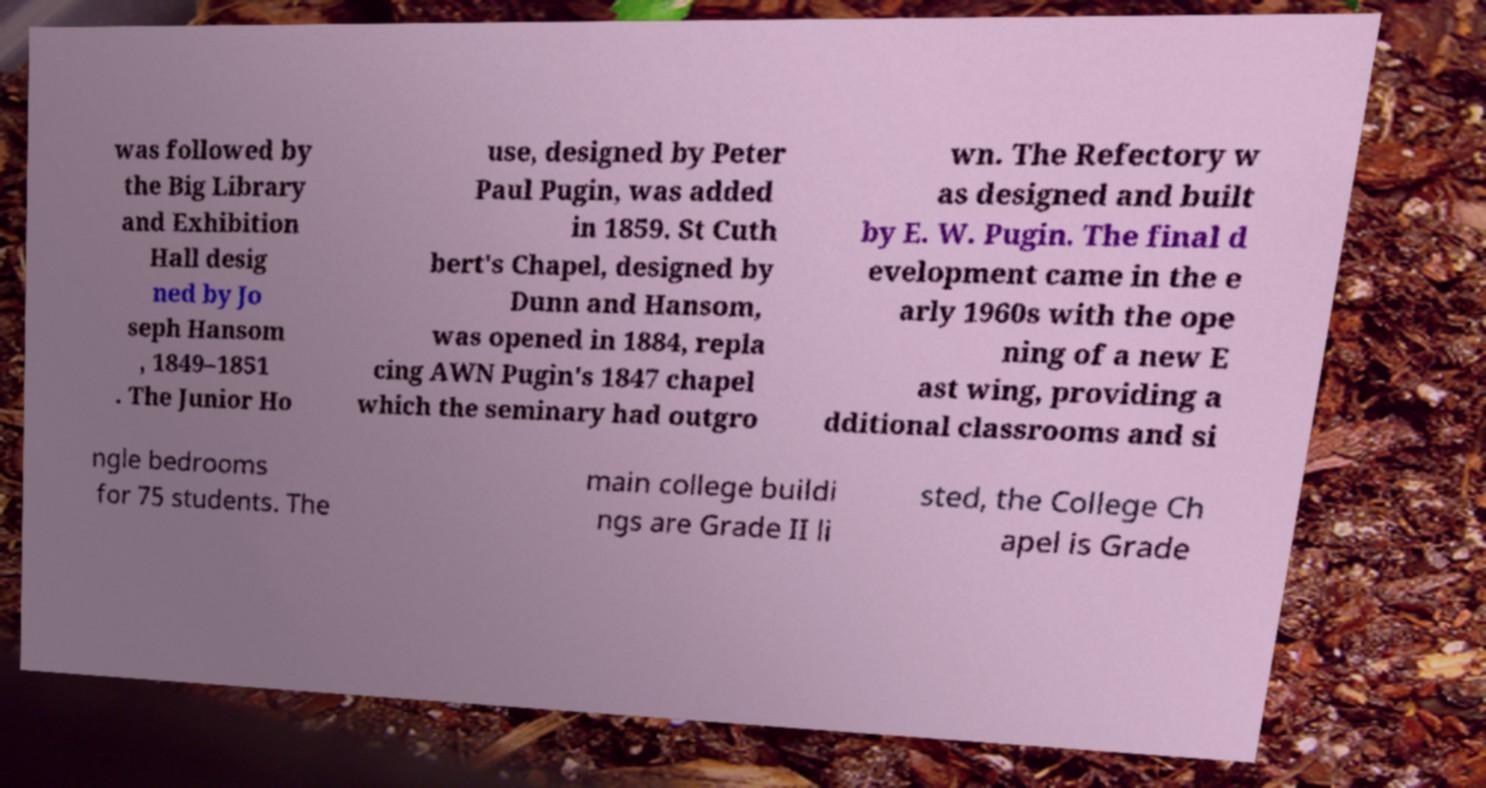Can you accurately transcribe the text from the provided image for me? was followed by the Big Library and Exhibition Hall desig ned by Jo seph Hansom , 1849–1851 . The Junior Ho use, designed by Peter Paul Pugin, was added in 1859. St Cuth bert's Chapel, designed by Dunn and Hansom, was opened in 1884, repla cing AWN Pugin's 1847 chapel which the seminary had outgro wn. The Refectory w as designed and built by E. W. Pugin. The final d evelopment came in the e arly 1960s with the ope ning of a new E ast wing, providing a dditional classrooms and si ngle bedrooms for 75 students. The main college buildi ngs are Grade II li sted, the College Ch apel is Grade 